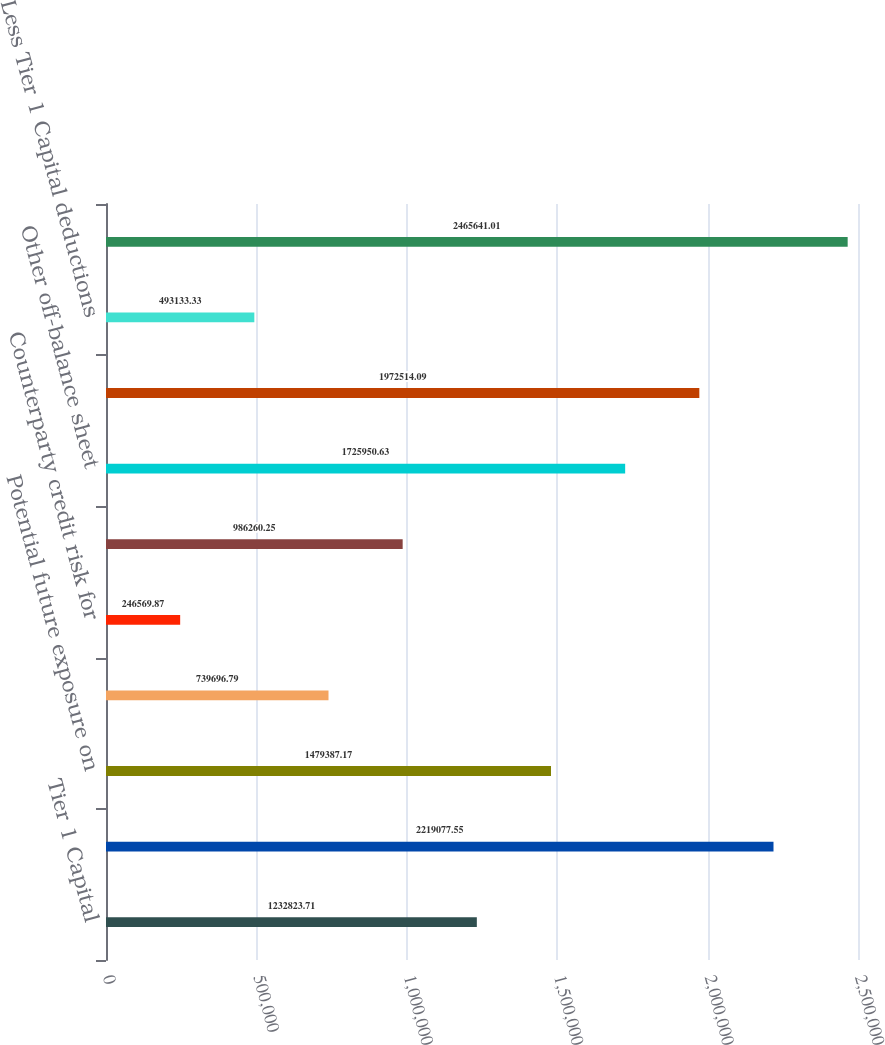Convert chart. <chart><loc_0><loc_0><loc_500><loc_500><bar_chart><fcel>Tier 1 Capital<fcel>On-balance sheet assets (1)<fcel>Potential future exposure on<fcel>Effective notional of sold<fcel>Counterparty credit risk for<fcel>Unconditionally cancelable<fcel>Other off-balance sheet<fcel>Total of certain off-balance<fcel>Less Tier 1 Capital deductions<fcel>Total Leverage Exposure<nl><fcel>1.23282e+06<fcel>2.21908e+06<fcel>1.47939e+06<fcel>739697<fcel>246570<fcel>986260<fcel>1.72595e+06<fcel>1.97251e+06<fcel>493133<fcel>2.46564e+06<nl></chart> 